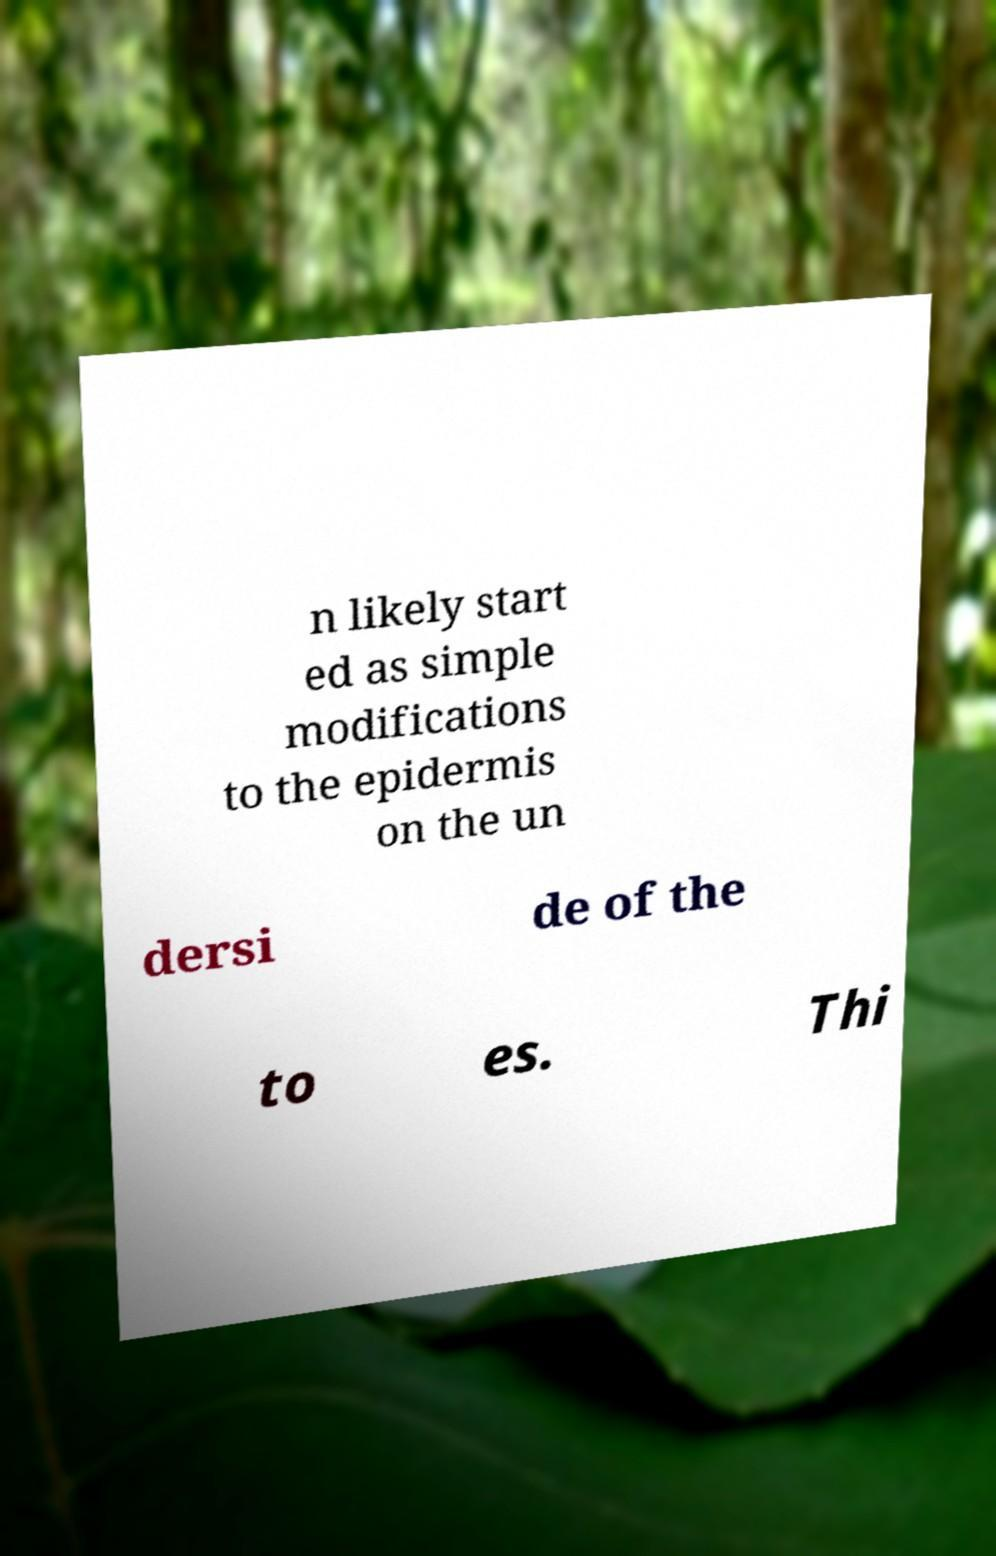Can you read and provide the text displayed in the image?This photo seems to have some interesting text. Can you extract and type it out for me? n likely start ed as simple modifications to the epidermis on the un dersi de of the to es. Thi 